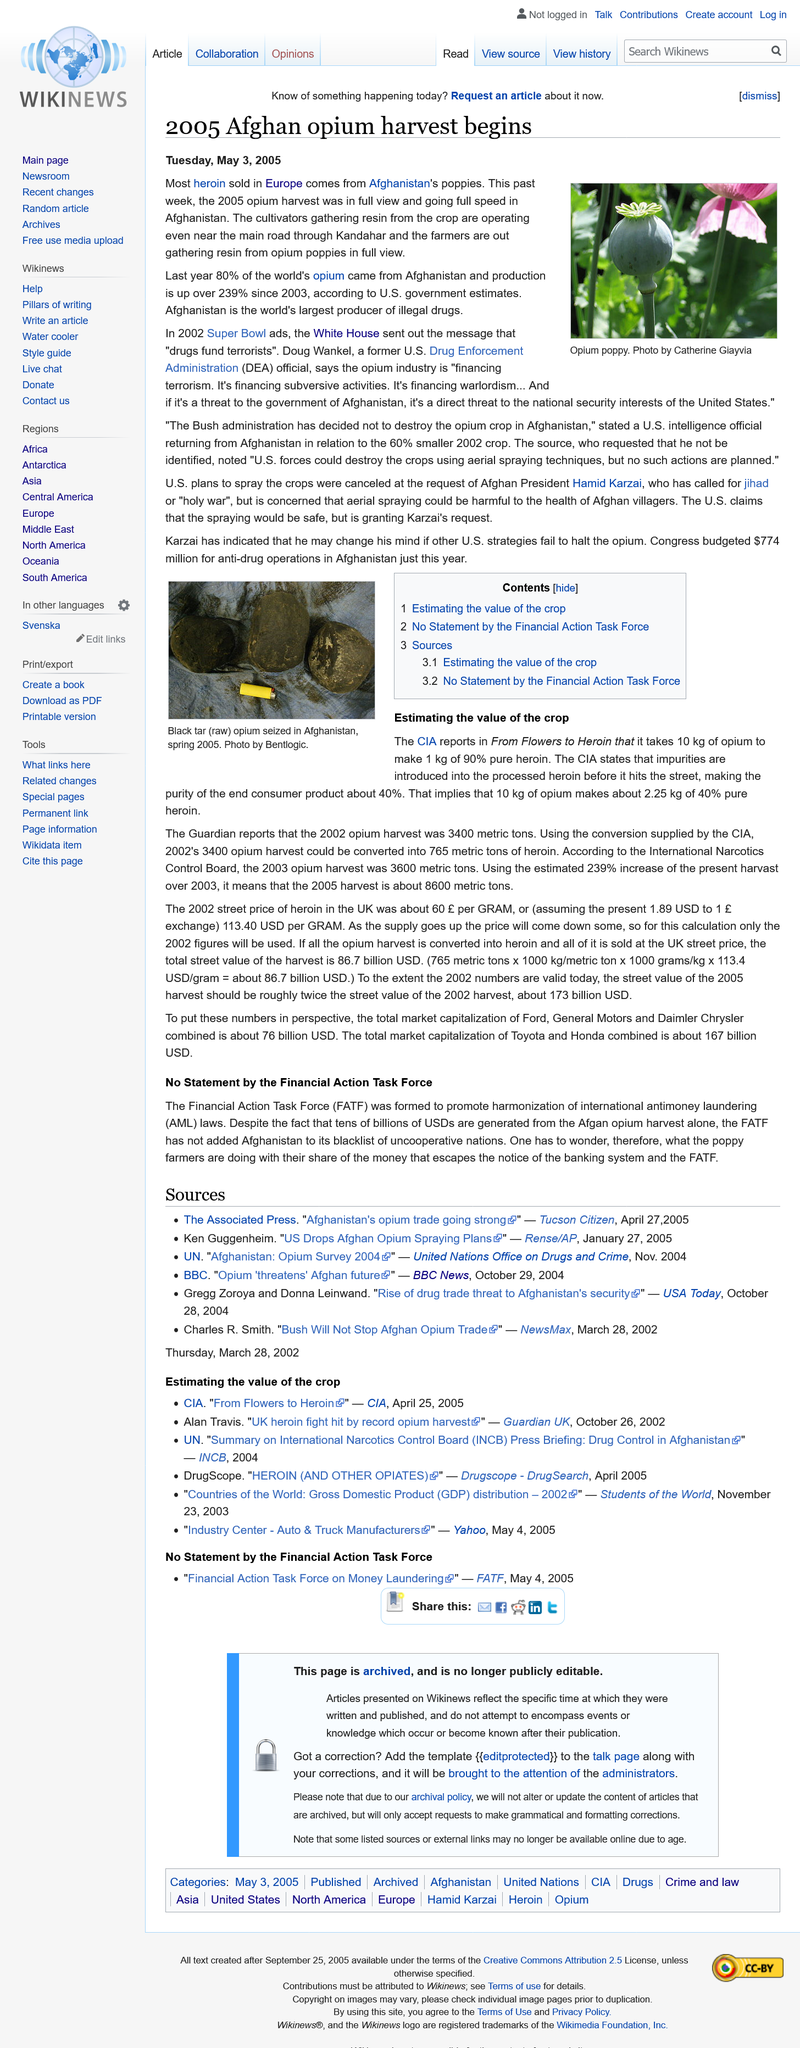List a handful of essential elements in this visual. The 2002 opium harvest, as reported by the Guardian, was 3400 metric tons. The purity of processed heroin when it hits the street, as stated by the CIA, is approximately 40%. The photograph of the opium poppy was taken by Catherine Giayvia and the author of the opium poppy photo is unknown. The majority of heroin sold in Europe is derived from poppies grown in Afghanistan. The article was published on Tuesday, May 3, 2005. 